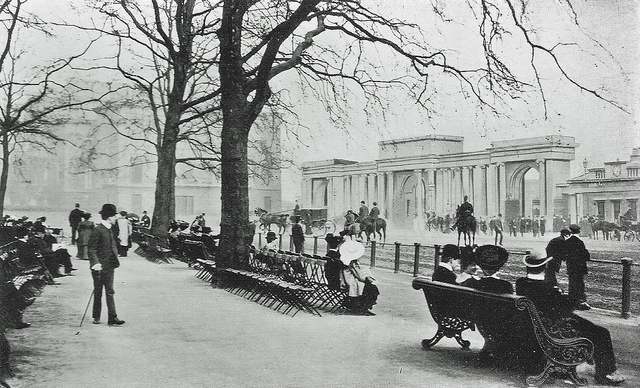<image>What is the architectural style of the building behind the people? It is ambiguous to determine the architectural style of the building behind the people. It can be seen as 'ancient', 'mesopotamia', 'roman', 'greek', 'gothic' or 'arch'. What is the architectural style of the building behind the people? I am not sure about the architectural style of the building behind the people. It can be seen ancient, Mesopotamia, Roman, Greek, Gothic, or Arch style. 